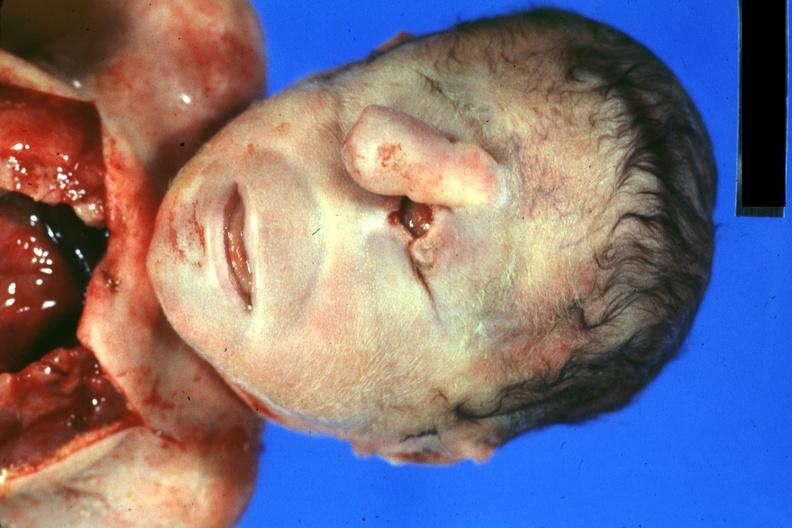s bicornate uterus present?
Answer the question using a single word or phrase. No 